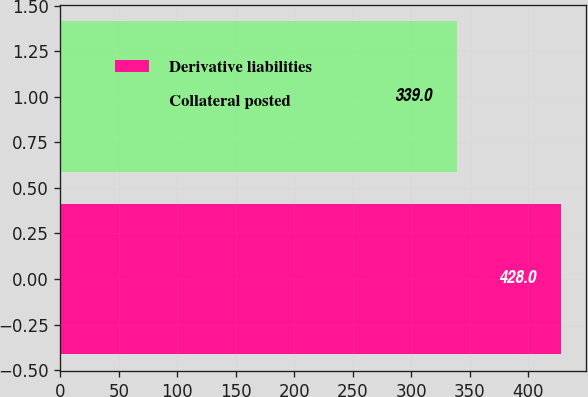<chart> <loc_0><loc_0><loc_500><loc_500><bar_chart><fcel>Derivative liabilities<fcel>Collateral posted<nl><fcel>428<fcel>339<nl></chart> 